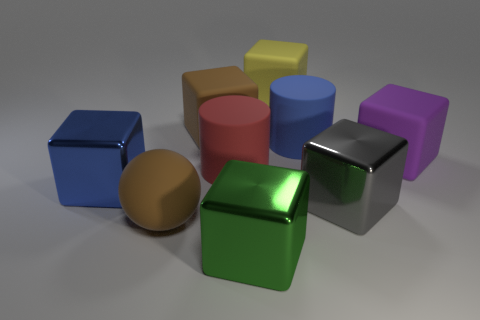There is a large ball that is the same material as the big red cylinder; what is its color? The large ball, which shares the same material as the big red cylinder, has a brown color, exhibiting a smooth and slightly reflective surface similar to the cylinder. 